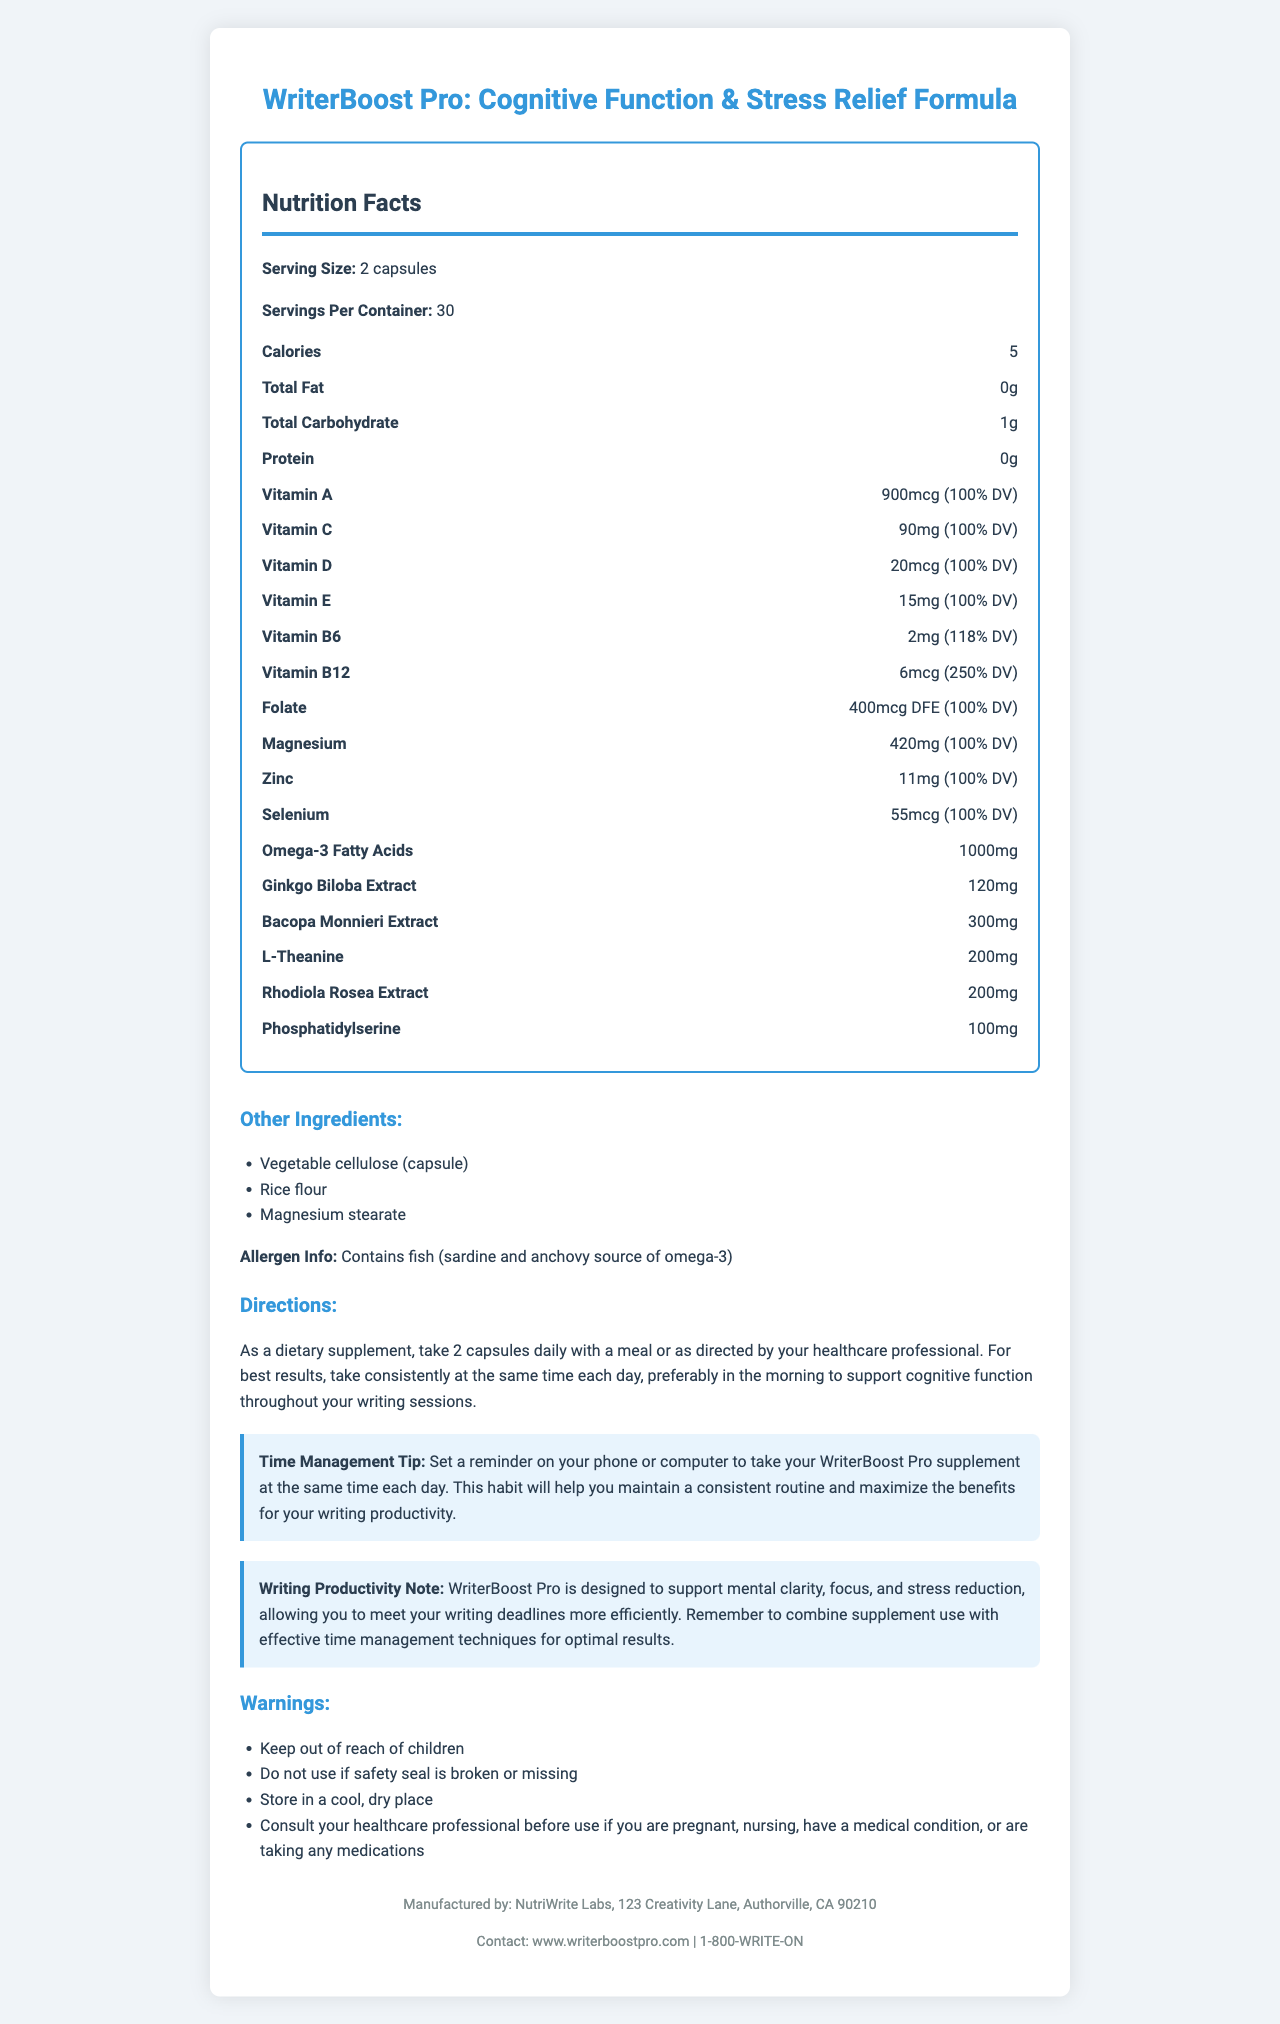what is the serving size? The document states that the serving size is 2 capsules.
Answer: 2 capsules how many servings are in one container? The document specifies that there are 30 servings per container.
Answer: 30 how many calories are in one serving? The document indicates that each serving contains 5 calories.
Answer: 5 what is the percentage daily value of Vitamin B12? The document shows that Vitamin B12 has a daily value of 250%.
Answer: 250% DV list one of the other ingredients in the supplement. The document lists Vegetable cellulose (capsule) as one of the other ingredients.
Answer: Vegetable cellulose (capsule) which of the following vitamins is included in this supplement at 100% of the daily value?
A. Vitamin B12
B. Vitamin C
C. Vitamin D
D. Vitamin B6 The document shows that Vitamin C is included in the supplement at 100% of the daily value.
Answer: B. Vitamin C what are the omega-3 fatty acids sourced from? The document notes that the omega-3 fatty acids are sourced from fish, specifically sardine and anchovy.
Answer: Fish (sardine and anchovy) what is the primary ingredient to support mental clarity and focus?
A. Bacopa Monnieri Extract
B. Ginkgo Biloba Extract
C. L-Theanine
D. Phosphatidylserine The document mentions that Bacopa Monnieri Extract is one of the ingredients aimed to support cognitive function, which includes mental clarity and focus.
Answer: A. Bacopa Monnieri Extract is this supplement designed to aid in reducing stress? The document states that the supplement is tailored to support cognitive function and reduce stress.
Answer: Yes what is the product designed to support? The document's writing productivity note explains that the supplement is designed to support mental clarity, focus, and stress reduction, enhancing writing productivity.
Answer: Mental clarity, focus, and stress reduction does the supplement contain protein? The document states that the supplement contains 0g of protein.
Answer: No who manufactures WriterBoost Pro? The document states that WriterBoost Pro is manufactured by NutriWrite Labs.
Answer: NutriWrite Labs what is recommended for best results when taking this supplement? The document's directions indicate that for best results, the supplement should be taken consistently at the same time each day, preferably in the morning.
Answer: To take consistently at the same time each day, preferably in the morning. are there any warnings associated with this supplement? List one. The document lists "Keep out of reach of children" as a warning associated with the supplement.
Answer: Keep out of reach of children. what is the main idea of this document? The document includes sections on nutritional facts, ingredients, directions, tips for use, warnings, and manufacturer information, all related to the WriterBoost Pro supplement designed for cognitive support and stress relief.
Answer: It provides detailed information about the WriterBoost Pro multivitamin supplement, including its nutritional facts, ingredients, directions for use, time management tips, warnings, and manufacturer details, aimed at supporting cognitive function and reducing stress for writers. does the document mention the expiry date of the supplement? The document does not provide any information regarding the expiry date of the supplement.
Answer: Cannot be determined 